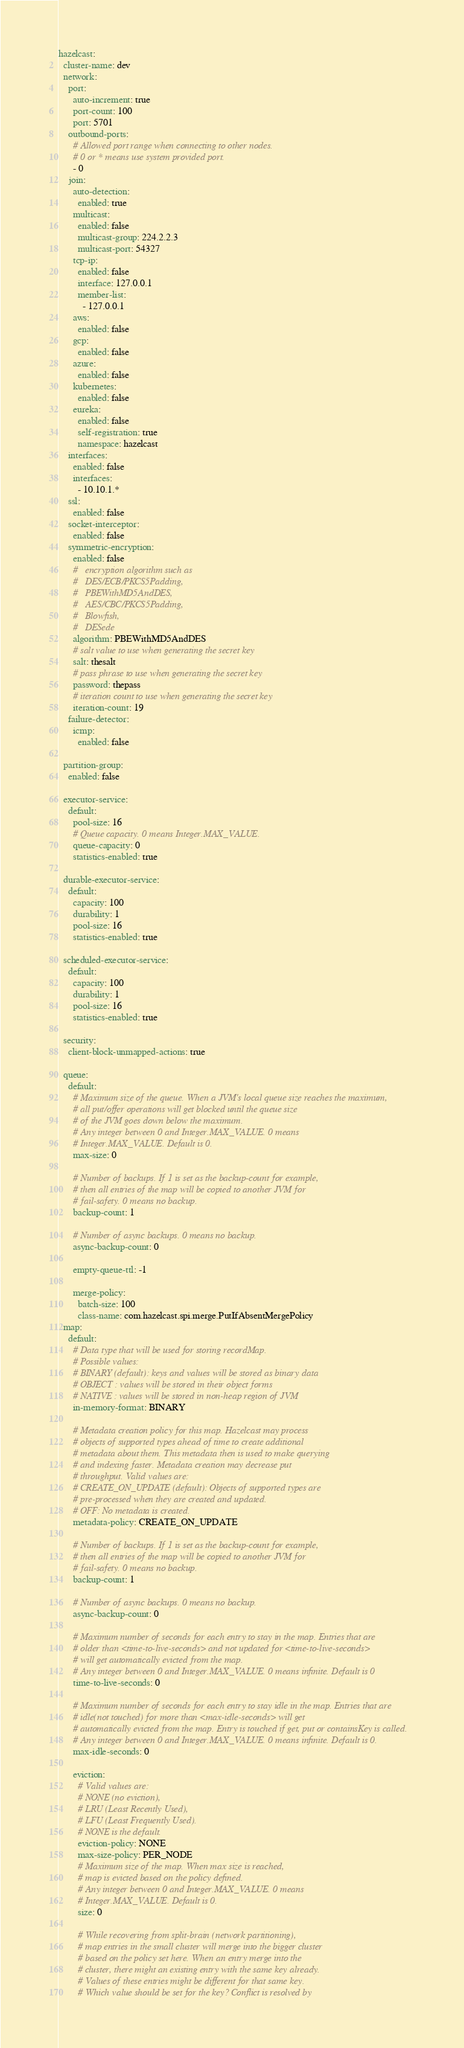Convert code to text. <code><loc_0><loc_0><loc_500><loc_500><_YAML_>hazelcast:
  cluster-name: dev
  network:
    port:
      auto-increment: true
      port-count: 100
      port: 5701
    outbound-ports:
      # Allowed port range when connecting to other nodes.
      # 0 or * means use system provided port.
      - 0
    join:
      auto-detection:
        enabled: true
      multicast:
        enabled: false
        multicast-group: 224.2.2.3
        multicast-port: 54327
      tcp-ip:
        enabled: false
        interface: 127.0.0.1
        member-list:
          - 127.0.0.1
      aws:
        enabled: false
      gcp:
        enabled: false
      azure:
        enabled: false
      kubernetes:
        enabled: false
      eureka:
        enabled: false
        self-registration: true
        namespace: hazelcast
    interfaces:
      enabled: false
      interfaces:
        - 10.10.1.*
    ssl:
      enabled: false
    socket-interceptor:
      enabled: false
    symmetric-encryption:
      enabled: false
      #   encryption algorithm such as
      #   DES/ECB/PKCS5Padding,
      #   PBEWithMD5AndDES,
      #   AES/CBC/PKCS5Padding,
      #   Blowfish,
      #   DESede
      algorithm: PBEWithMD5AndDES
      # salt value to use when generating the secret key
      salt: thesalt
      # pass phrase to use when generating the secret key
      password: thepass
      # iteration count to use when generating the secret key
      iteration-count: 19
    failure-detector:
      icmp:
        enabled: false

  partition-group:
    enabled: false

  executor-service:
    default:
      pool-size: 16
      # Queue capacity. 0 means Integer.MAX_VALUE.
      queue-capacity: 0
      statistics-enabled: true

  durable-executor-service:
    default:
      capacity: 100
      durability: 1
      pool-size: 16
      statistics-enabled: true

  scheduled-executor-service:
    default:
      capacity: 100
      durability: 1
      pool-size: 16
      statistics-enabled: true

  security:
    client-block-unmapped-actions: true

  queue:
    default:
      # Maximum size of the queue. When a JVM's local queue size reaches the maximum,
      # all put/offer operations will get blocked until the queue size
      # of the JVM goes down below the maximum.
      # Any integer between 0 and Integer.MAX_VALUE. 0 means
      # Integer.MAX_VALUE. Default is 0.
      max-size: 0

      # Number of backups. If 1 is set as the backup-count for example,
      # then all entries of the map will be copied to another JVM for
      # fail-safety. 0 means no backup.
      backup-count: 1

      # Number of async backups. 0 means no backup.
      async-backup-count: 0

      empty-queue-ttl: -1

      merge-policy:
        batch-size: 100
        class-name: com.hazelcast.spi.merge.PutIfAbsentMergePolicy
  map:
    default:
      # Data type that will be used for storing recordMap.
      # Possible values:
      # BINARY (default): keys and values will be stored as binary data
      # OBJECT : values will be stored in their object forms
      # NATIVE : values will be stored in non-heap region of JVM
      in-memory-format: BINARY

      # Metadata creation policy for this map. Hazelcast may process
      # objects of supported types ahead of time to create additional
      # metadata about them. This metadata then is used to make querying
      # and indexing faster. Metadata creation may decrease put
      # throughput. Valid values are:
      # CREATE_ON_UPDATE (default): Objects of supported types are
      # pre-processed when they are created and updated.
      # OFF: No metadata is created.
      metadata-policy: CREATE_ON_UPDATE

      # Number of backups. If 1 is set as the backup-count for example,
      # then all entries of the map will be copied to another JVM for
      # fail-safety. 0 means no backup.
      backup-count: 1

      # Number of async backups. 0 means no backup.
      async-backup-count: 0

      # Maximum number of seconds for each entry to stay in the map. Entries that are
      # older than <time-to-live-seconds> and not updated for <time-to-live-seconds>
      # will get automatically evicted from the map.
      # Any integer between 0 and Integer.MAX_VALUE. 0 means infinite. Default is 0
      time-to-live-seconds: 0

      # Maximum number of seconds for each entry to stay idle in the map. Entries that are
      # idle(not touched) for more than <max-idle-seconds> will get
      # automatically evicted from the map. Entry is touched if get, put or containsKey is called.
      # Any integer between 0 and Integer.MAX_VALUE. 0 means infinite. Default is 0.
      max-idle-seconds: 0

      eviction:
        # Valid values are:
        # NONE (no eviction),
        # LRU (Least Recently Used),
        # LFU (Least Frequently Used).
        # NONE is the default.
        eviction-policy: NONE
        max-size-policy: PER_NODE
        # Maximum size of the map. When max size is reached,
        # map is evicted based on the policy defined.
        # Any integer between 0 and Integer.MAX_VALUE. 0 means
        # Integer.MAX_VALUE. Default is 0.
        size: 0

        # While recovering from split-brain (network partitioning),
        # map entries in the small cluster will merge into the bigger cluster
        # based on the policy set here. When an entry merge into the
        # cluster, there might an existing entry with the same key already.
        # Values of these entries might be different for that same key.
        # Which value should be set for the key? Conflict is resolved by</code> 